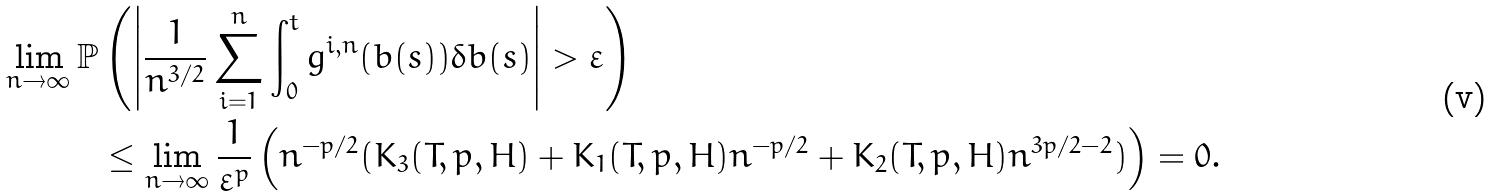<formula> <loc_0><loc_0><loc_500><loc_500>\lim _ { n \rightarrow \infty } \mathbb { P } & \left ( \left | \frac { 1 } { n ^ { 3 / 2 } } \sum _ { i = 1 } ^ { n } \int _ { 0 } ^ { t } g ^ { i , n } ( b ( s ) ) \delta b ( s ) \right | > \varepsilon \right ) \\ & \leq \lim _ { n \rightarrow \infty } \frac { 1 } { \varepsilon ^ { p } } \left ( n ^ { - p / 2 } ( K _ { 3 } ( T , p , H ) + K _ { 1 } ( T , p , H ) n ^ { - p / 2 } + K _ { 2 } ( T , p , H ) n ^ { 3 p / 2 - 2 } ) \right ) = 0 .</formula> 